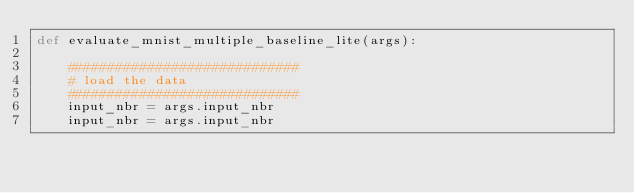<code> <loc_0><loc_0><loc_500><loc_500><_Python_>def evaluate_mnist_multiple_baseline_lite(args):

    #############################
    # load the data
    #############################
    input_nbr = args.input_nbr
    input_nbr = args.input_nbr
</code> 